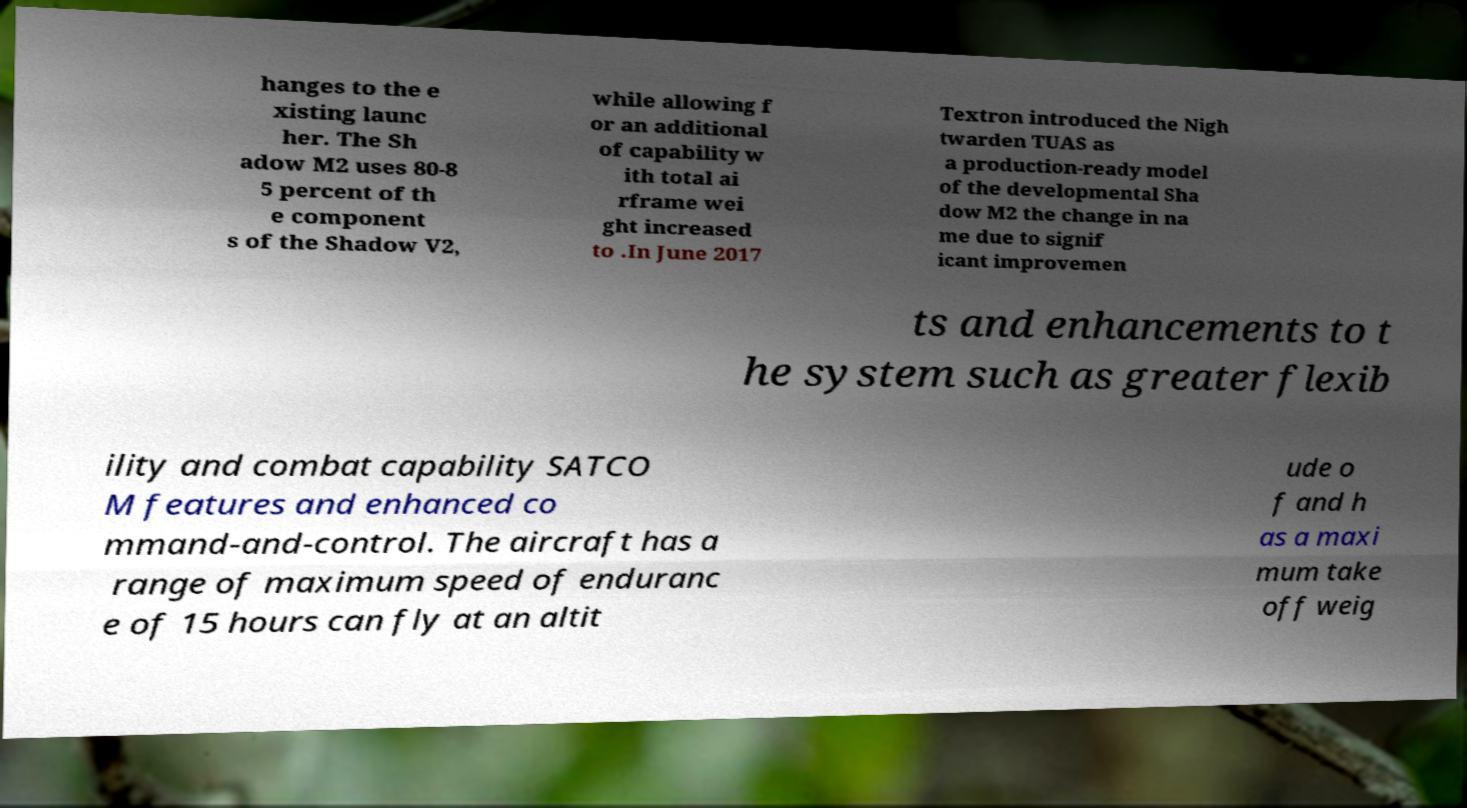There's text embedded in this image that I need extracted. Can you transcribe it verbatim? hanges to the e xisting launc her. The Sh adow M2 uses 80-8 5 percent of th e component s of the Shadow V2, while allowing f or an additional of capability w ith total ai rframe wei ght increased to .In June 2017 Textron introduced the Nigh twarden TUAS as a production-ready model of the developmental Sha dow M2 the change in na me due to signif icant improvemen ts and enhancements to t he system such as greater flexib ility and combat capability SATCO M features and enhanced co mmand-and-control. The aircraft has a range of maximum speed of enduranc e of 15 hours can fly at an altit ude o f and h as a maxi mum take off weig 